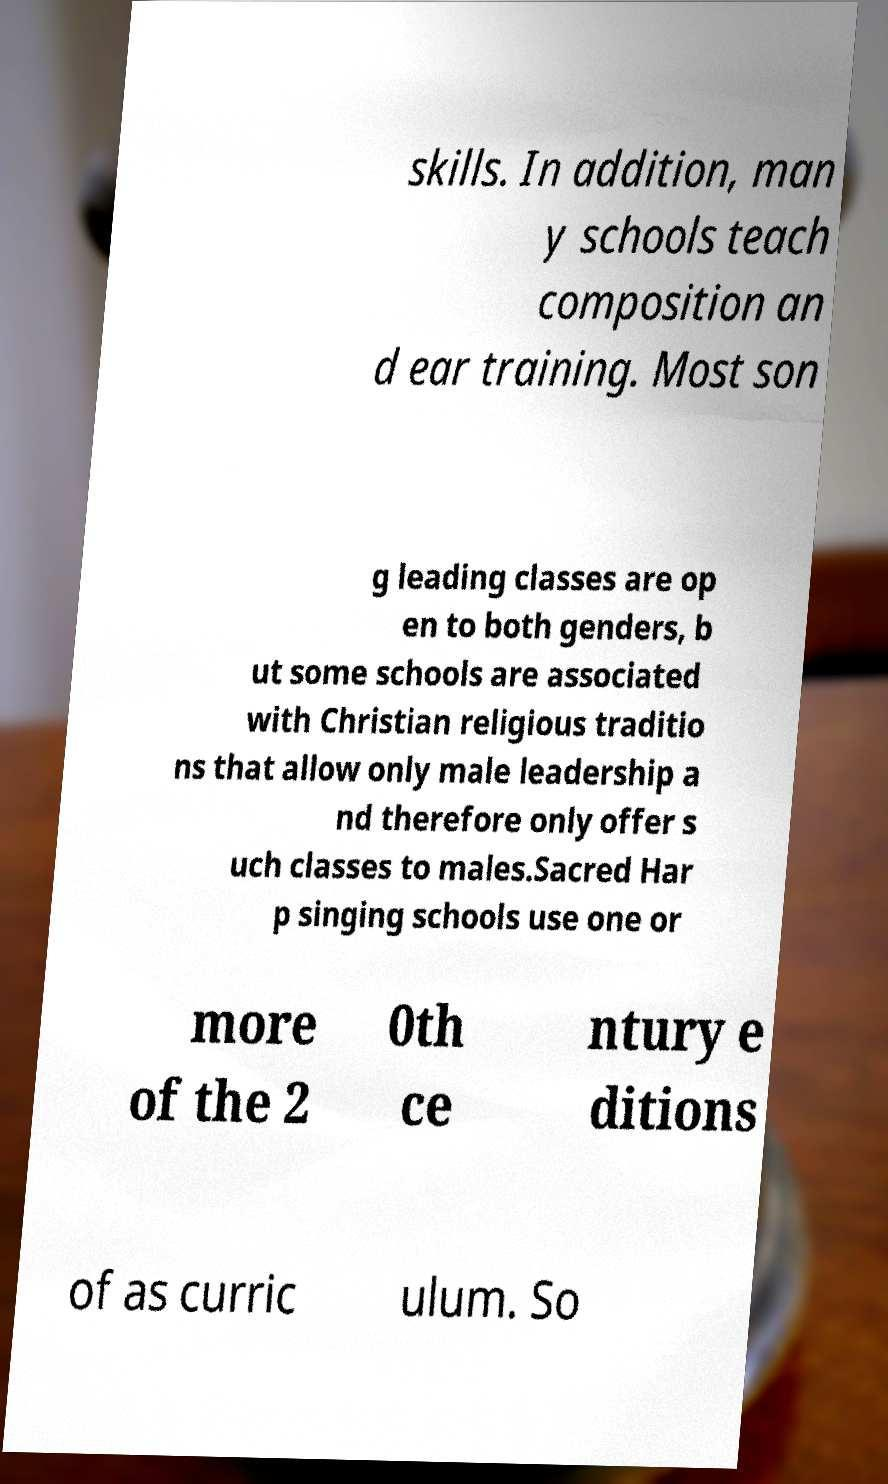Can you accurately transcribe the text from the provided image for me? skills. In addition, man y schools teach composition an d ear training. Most son g leading classes are op en to both genders, b ut some schools are associated with Christian religious traditio ns that allow only male leadership a nd therefore only offer s uch classes to males.Sacred Har p singing schools use one or more of the 2 0th ce ntury e ditions of as curric ulum. So 